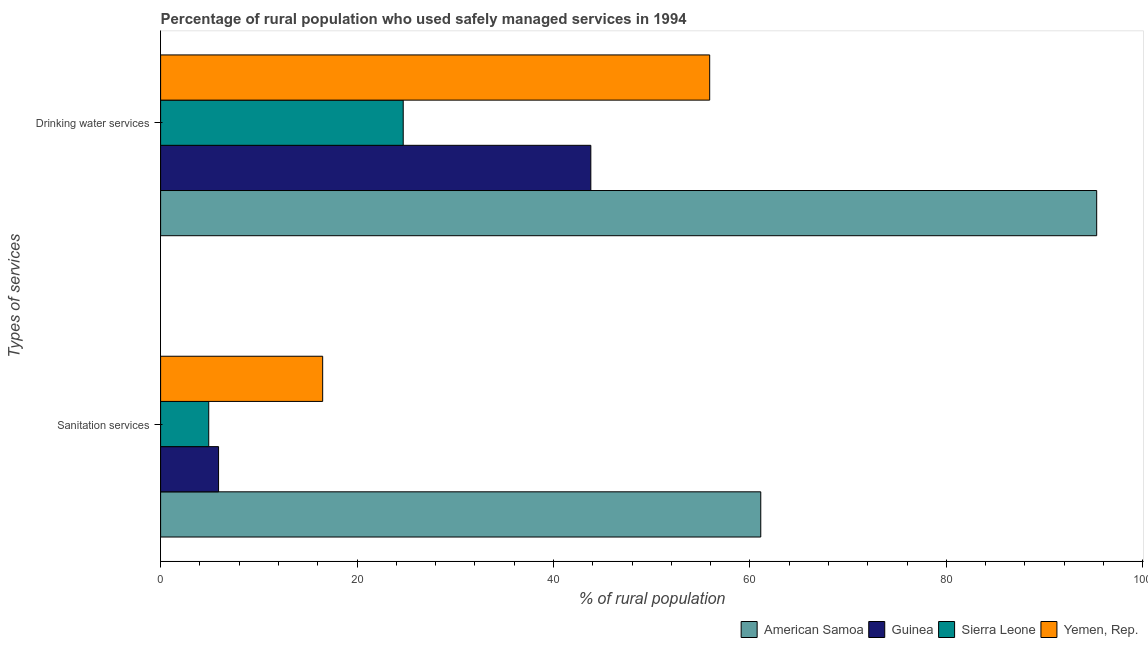How many different coloured bars are there?
Offer a very short reply. 4. How many bars are there on the 1st tick from the top?
Provide a short and direct response. 4. How many bars are there on the 2nd tick from the bottom?
Ensure brevity in your answer.  4. What is the label of the 1st group of bars from the top?
Your response must be concise. Drinking water services. What is the percentage of rural population who used drinking water services in American Samoa?
Offer a terse response. 95.3. Across all countries, what is the maximum percentage of rural population who used sanitation services?
Provide a succinct answer. 61.1. Across all countries, what is the minimum percentage of rural population who used sanitation services?
Offer a very short reply. 4.9. In which country was the percentage of rural population who used drinking water services maximum?
Offer a terse response. American Samoa. In which country was the percentage of rural population who used sanitation services minimum?
Ensure brevity in your answer.  Sierra Leone. What is the total percentage of rural population who used sanitation services in the graph?
Your response must be concise. 88.4. What is the difference between the percentage of rural population who used drinking water services in Sierra Leone and the percentage of rural population who used sanitation services in Guinea?
Your answer should be very brief. 18.8. What is the average percentage of rural population who used drinking water services per country?
Make the answer very short. 54.92. What is the difference between the percentage of rural population who used sanitation services and percentage of rural population who used drinking water services in American Samoa?
Your answer should be compact. -34.2. What is the ratio of the percentage of rural population who used sanitation services in Sierra Leone to that in American Samoa?
Offer a very short reply. 0.08. Is the percentage of rural population who used sanitation services in Guinea less than that in Yemen, Rep.?
Your answer should be very brief. Yes. In how many countries, is the percentage of rural population who used sanitation services greater than the average percentage of rural population who used sanitation services taken over all countries?
Provide a short and direct response. 1. What does the 2nd bar from the top in Sanitation services represents?
Ensure brevity in your answer.  Sierra Leone. What does the 1st bar from the bottom in Drinking water services represents?
Keep it short and to the point. American Samoa. Are all the bars in the graph horizontal?
Provide a short and direct response. Yes. How many countries are there in the graph?
Provide a short and direct response. 4. Does the graph contain any zero values?
Make the answer very short. No. Where does the legend appear in the graph?
Give a very brief answer. Bottom right. What is the title of the graph?
Your answer should be very brief. Percentage of rural population who used safely managed services in 1994. What is the label or title of the X-axis?
Your answer should be compact. % of rural population. What is the label or title of the Y-axis?
Provide a succinct answer. Types of services. What is the % of rural population of American Samoa in Sanitation services?
Provide a short and direct response. 61.1. What is the % of rural population of American Samoa in Drinking water services?
Your answer should be very brief. 95.3. What is the % of rural population in Guinea in Drinking water services?
Your answer should be very brief. 43.8. What is the % of rural population in Sierra Leone in Drinking water services?
Give a very brief answer. 24.7. What is the % of rural population in Yemen, Rep. in Drinking water services?
Offer a very short reply. 55.9. Across all Types of services, what is the maximum % of rural population of American Samoa?
Provide a short and direct response. 95.3. Across all Types of services, what is the maximum % of rural population of Guinea?
Give a very brief answer. 43.8. Across all Types of services, what is the maximum % of rural population in Sierra Leone?
Provide a short and direct response. 24.7. Across all Types of services, what is the maximum % of rural population in Yemen, Rep.?
Ensure brevity in your answer.  55.9. Across all Types of services, what is the minimum % of rural population of American Samoa?
Keep it short and to the point. 61.1. Across all Types of services, what is the minimum % of rural population in Sierra Leone?
Give a very brief answer. 4.9. Across all Types of services, what is the minimum % of rural population in Yemen, Rep.?
Ensure brevity in your answer.  16.5. What is the total % of rural population in American Samoa in the graph?
Ensure brevity in your answer.  156.4. What is the total % of rural population of Guinea in the graph?
Offer a very short reply. 49.7. What is the total % of rural population in Sierra Leone in the graph?
Provide a short and direct response. 29.6. What is the total % of rural population of Yemen, Rep. in the graph?
Provide a succinct answer. 72.4. What is the difference between the % of rural population of American Samoa in Sanitation services and that in Drinking water services?
Provide a succinct answer. -34.2. What is the difference between the % of rural population in Guinea in Sanitation services and that in Drinking water services?
Give a very brief answer. -37.9. What is the difference between the % of rural population in Sierra Leone in Sanitation services and that in Drinking water services?
Your answer should be compact. -19.8. What is the difference between the % of rural population of Yemen, Rep. in Sanitation services and that in Drinking water services?
Make the answer very short. -39.4. What is the difference between the % of rural population in American Samoa in Sanitation services and the % of rural population in Guinea in Drinking water services?
Your response must be concise. 17.3. What is the difference between the % of rural population in American Samoa in Sanitation services and the % of rural population in Sierra Leone in Drinking water services?
Give a very brief answer. 36.4. What is the difference between the % of rural population of Guinea in Sanitation services and the % of rural population of Sierra Leone in Drinking water services?
Offer a terse response. -18.8. What is the difference between the % of rural population in Sierra Leone in Sanitation services and the % of rural population in Yemen, Rep. in Drinking water services?
Your answer should be very brief. -51. What is the average % of rural population in American Samoa per Types of services?
Your response must be concise. 78.2. What is the average % of rural population in Guinea per Types of services?
Ensure brevity in your answer.  24.85. What is the average % of rural population of Yemen, Rep. per Types of services?
Your response must be concise. 36.2. What is the difference between the % of rural population of American Samoa and % of rural population of Guinea in Sanitation services?
Give a very brief answer. 55.2. What is the difference between the % of rural population in American Samoa and % of rural population in Sierra Leone in Sanitation services?
Provide a short and direct response. 56.2. What is the difference between the % of rural population of American Samoa and % of rural population of Yemen, Rep. in Sanitation services?
Your answer should be compact. 44.6. What is the difference between the % of rural population of American Samoa and % of rural population of Guinea in Drinking water services?
Give a very brief answer. 51.5. What is the difference between the % of rural population in American Samoa and % of rural population in Sierra Leone in Drinking water services?
Give a very brief answer. 70.6. What is the difference between the % of rural population in American Samoa and % of rural population in Yemen, Rep. in Drinking water services?
Make the answer very short. 39.4. What is the difference between the % of rural population of Sierra Leone and % of rural population of Yemen, Rep. in Drinking water services?
Offer a very short reply. -31.2. What is the ratio of the % of rural population in American Samoa in Sanitation services to that in Drinking water services?
Offer a terse response. 0.64. What is the ratio of the % of rural population in Guinea in Sanitation services to that in Drinking water services?
Ensure brevity in your answer.  0.13. What is the ratio of the % of rural population of Sierra Leone in Sanitation services to that in Drinking water services?
Your answer should be very brief. 0.2. What is the ratio of the % of rural population of Yemen, Rep. in Sanitation services to that in Drinking water services?
Provide a short and direct response. 0.3. What is the difference between the highest and the second highest % of rural population of American Samoa?
Ensure brevity in your answer.  34.2. What is the difference between the highest and the second highest % of rural population of Guinea?
Offer a very short reply. 37.9. What is the difference between the highest and the second highest % of rural population in Sierra Leone?
Offer a very short reply. 19.8. What is the difference between the highest and the second highest % of rural population of Yemen, Rep.?
Make the answer very short. 39.4. What is the difference between the highest and the lowest % of rural population of American Samoa?
Offer a very short reply. 34.2. What is the difference between the highest and the lowest % of rural population of Guinea?
Provide a short and direct response. 37.9. What is the difference between the highest and the lowest % of rural population in Sierra Leone?
Make the answer very short. 19.8. What is the difference between the highest and the lowest % of rural population in Yemen, Rep.?
Provide a short and direct response. 39.4. 